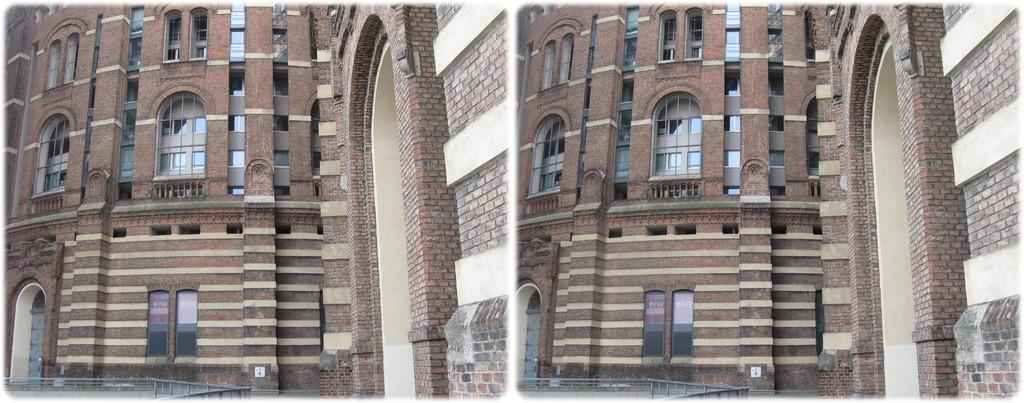What type of structure is visible in the image? There is a building in the image. What architectural feature can be seen on the building? There are iron grilles in the image. Where is the crib located in the image? There is no crib present in the image. What type of leaf can be seen on the building in the image? There are no leaves visible on the building in the image. 